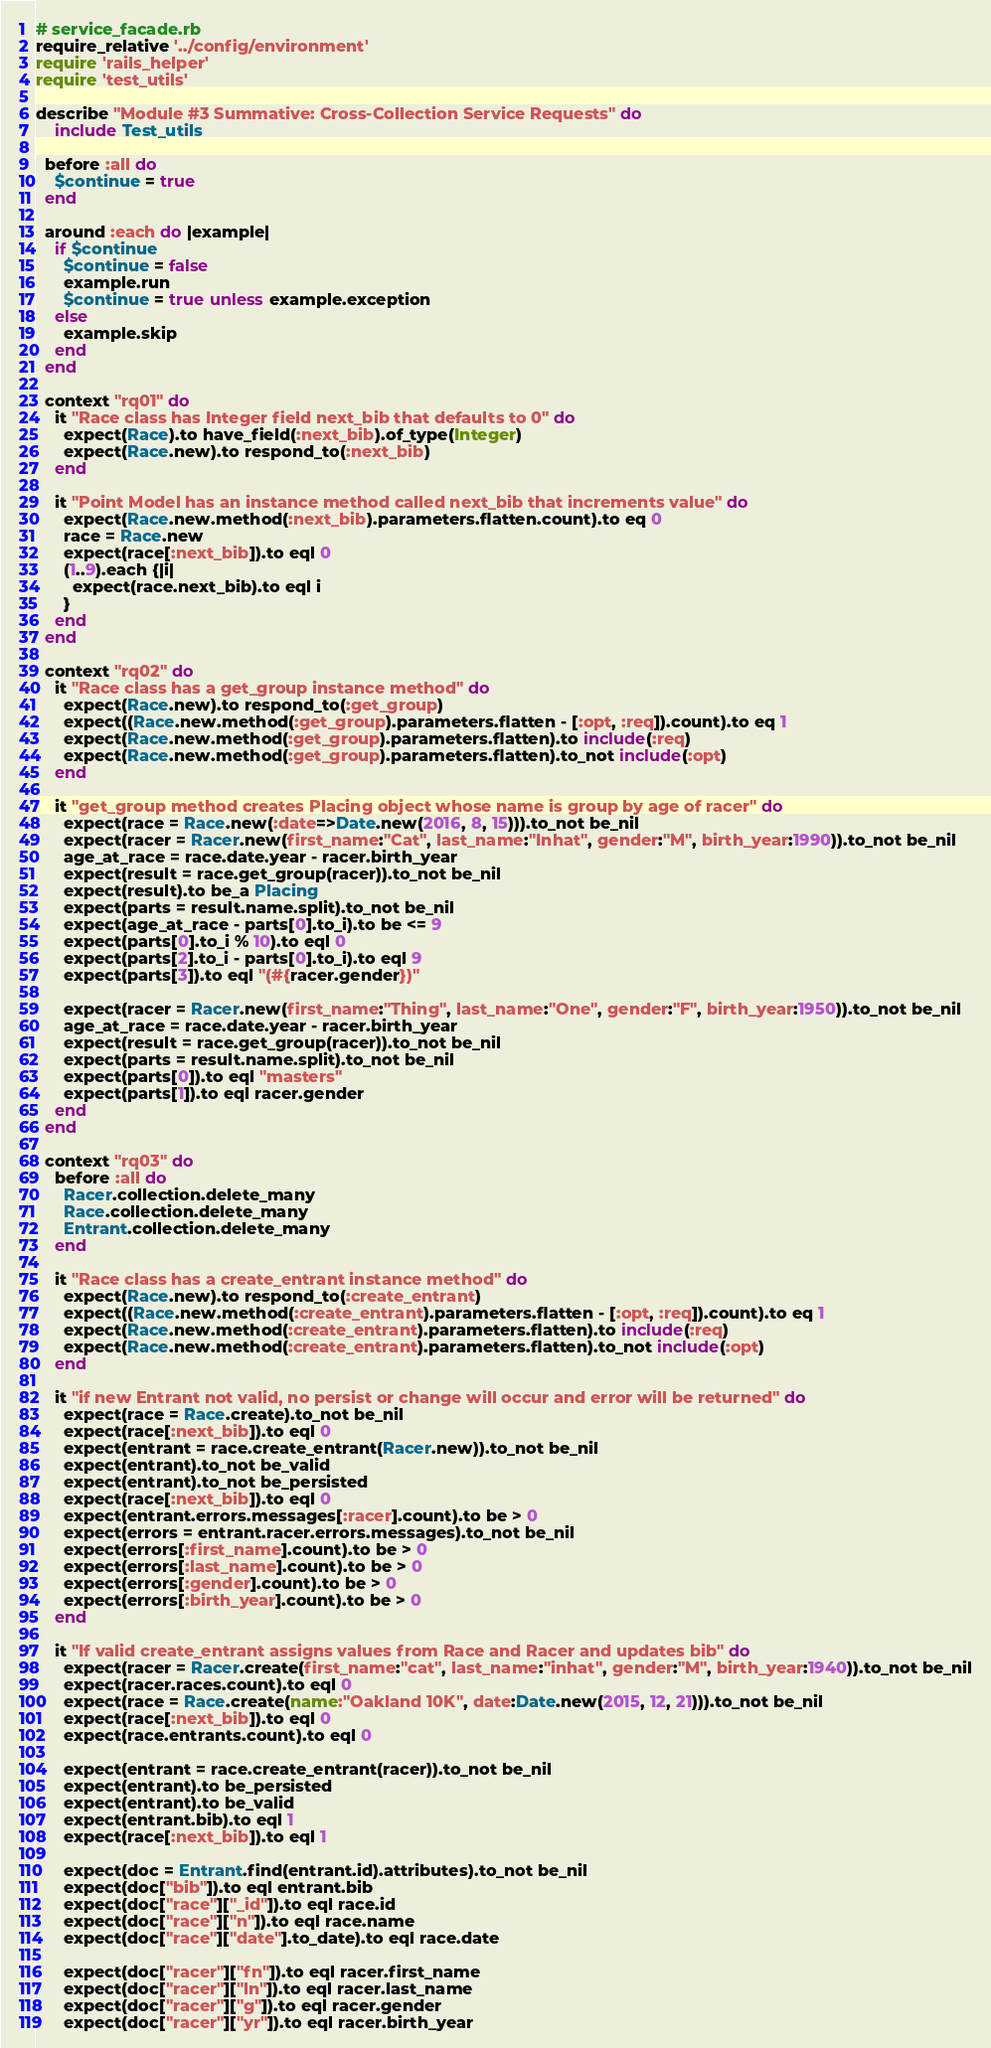<code> <loc_0><loc_0><loc_500><loc_500><_Ruby_># service_facade.rb
require_relative '../config/environment'
require 'rails_helper'
require 'test_utils'

describe "Module #3 Summative: Cross-Collection Service Requests" do
	include Test_utils

  before :all do
    $continue = true
  end

  around :each do |example|
    if $continue
      $continue = false 
      example.run 
      $continue = true unless example.exception
    else
      example.skip
    end
  end

  context "rq01" do 
    it "Race class has Integer field next_bib that defaults to 0" do
      expect(Race).to have_field(:next_bib).of_type(Integer)
      expect(Race.new).to respond_to(:next_bib)
    end

    it "Point Model has an instance method called next_bib that increments value" do
      expect(Race.new.method(:next_bib).parameters.flatten.count).to eq 0      
      race = Race.new
      expect(race[:next_bib]).to eql 0
      (1..9).each {|i| 
        expect(race.next_bib).to eql i
      }
    end
  end  

  context "rq02" do 
    it "Race class has a get_group instance method" do
      expect(Race.new).to respond_to(:get_group)
      expect((Race.new.method(:get_group).parameters.flatten - [:opt, :req]).count).to eq 1            
      expect(Race.new.method(:get_group).parameters.flatten).to include(:req)        
      expect(Race.new.method(:get_group).parameters.flatten).to_not include(:opt)        
    end

    it "get_group method creates Placing object whose name is group by age of racer" do
      expect(race = Race.new(:date=>Date.new(2016, 8, 15))).to_not be_nil
      expect(racer = Racer.new(first_name:"Cat", last_name:"Inhat", gender:"M", birth_year:1990)).to_not be_nil
      age_at_race = race.date.year - racer.birth_year
      expect(result = race.get_group(racer)).to_not be_nil
      expect(result).to be_a Placing
      expect(parts = result.name.split).to_not be_nil
      expect(age_at_race - parts[0].to_i).to be <= 9
      expect(parts[0].to_i % 10).to eql 0
      expect(parts[2].to_i - parts[0].to_i).to eql 9
      expect(parts[3]).to eql "(#{racer.gender})"

      expect(racer = Racer.new(first_name:"Thing", last_name:"One", gender:"F", birth_year:1950)).to_not be_nil
      age_at_race = race.date.year - racer.birth_year
      expect(result = race.get_group(racer)).to_not be_nil
      expect(parts = result.name.split).to_not be_nil
      expect(parts[0]).to eql "masters"
      expect(parts[1]).to eql racer.gender
    end
  end

  context "rq03" do 
    before :all do
      Racer.collection.delete_many
      Race.collection.delete_many
      Entrant.collection.delete_many
    end

    it "Race class has a create_entrant instance method" do
      expect(Race.new).to respond_to(:create_entrant)
      expect((Race.new.method(:create_entrant).parameters.flatten - [:opt, :req]).count).to eq 1            
      expect(Race.new.method(:create_entrant).parameters.flatten).to include(:req)        
      expect(Race.new.method(:create_entrant).parameters.flatten).to_not include(:opt)        
    end

    it "if new Entrant not valid, no persist or change will occur and error will be returned" do
      expect(race = Race.create).to_not be_nil
      expect(race[:next_bib]).to eql 0
      expect(entrant = race.create_entrant(Racer.new)).to_not be_nil
      expect(entrant).to_not be_valid
      expect(entrant).to_not be_persisted
      expect(race[:next_bib]).to eql 0
      expect(entrant.errors.messages[:racer].count).to be > 0
      expect(errors = entrant.racer.errors.messages).to_not be_nil
      expect(errors[:first_name].count).to be > 0
      expect(errors[:last_name].count).to be > 0
      expect(errors[:gender].count).to be > 0
      expect(errors[:birth_year].count).to be > 0
    end

    it "If valid create_entrant assigns values from Race and Racer and updates bib" do
      expect(racer = Racer.create(first_name:"cat", last_name:"inhat", gender:"M", birth_year:1940)).to_not be_nil
      expect(racer.races.count).to eql 0
      expect(race = Race.create(name:"Oakland 10K", date:Date.new(2015, 12, 21))).to_not be_nil
      expect(race[:next_bib]).to eql 0
      expect(race.entrants.count).to eql 0

      expect(entrant = race.create_entrant(racer)).to_not be_nil
      expect(entrant).to be_persisted
      expect(entrant).to be_valid
      expect(entrant.bib).to eql 1
      expect(race[:next_bib]).to eql 1

      expect(doc = Entrant.find(entrant.id).attributes).to_not be_nil
      expect(doc["bib"]).to eql entrant.bib
      expect(doc["race"]["_id"]).to eql race.id
      expect(doc["race"]["n"]).to eql race.name
      expect(doc["race"]["date"].to_date).to eql race.date

      expect(doc["racer"]["fn"]).to eql racer.first_name
      expect(doc["racer"]["ln"]).to eql racer.last_name
      expect(doc["racer"]["g"]).to eql racer.gender
      expect(doc["racer"]["yr"]).to eql racer.birth_year</code> 